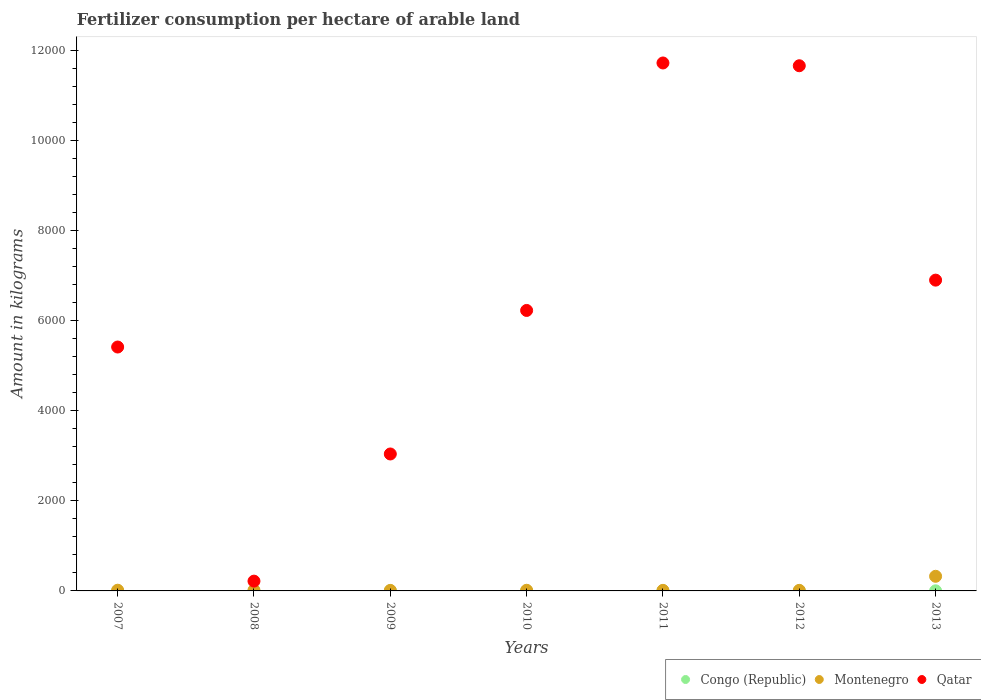How many different coloured dotlines are there?
Offer a terse response. 3. What is the amount of fertilizer consumption in Montenegro in 2011?
Make the answer very short. 12.55. Across all years, what is the maximum amount of fertilizer consumption in Montenegro?
Give a very brief answer. 324.74. Across all years, what is the minimum amount of fertilizer consumption in Montenegro?
Provide a short and direct response. 11.33. In which year was the amount of fertilizer consumption in Congo (Republic) maximum?
Provide a short and direct response. 2009. In which year was the amount of fertilizer consumption in Congo (Republic) minimum?
Make the answer very short. 2007. What is the total amount of fertilizer consumption in Congo (Republic) in the graph?
Your answer should be compact. 10.15. What is the difference between the amount of fertilizer consumption in Montenegro in 2010 and that in 2013?
Your answer should be compact. -310.39. What is the difference between the amount of fertilizer consumption in Congo (Republic) in 2013 and the amount of fertilizer consumption in Montenegro in 2010?
Your answer should be very brief. -12.07. What is the average amount of fertilizer consumption in Montenegro per year?
Offer a very short reply. 57.97. In the year 2011, what is the difference between the amount of fertilizer consumption in Congo (Republic) and amount of fertilizer consumption in Qatar?
Your answer should be compact. -1.17e+04. What is the ratio of the amount of fertilizer consumption in Qatar in 2011 to that in 2013?
Your answer should be compact. 1.7. Is the amount of fertilizer consumption in Congo (Republic) in 2008 less than that in 2010?
Ensure brevity in your answer.  No. What is the difference between the highest and the second highest amount of fertilizer consumption in Congo (Republic)?
Provide a succinct answer. 2.3. What is the difference between the highest and the lowest amount of fertilizer consumption in Montenegro?
Offer a terse response. 313.41. In how many years, is the amount of fertilizer consumption in Qatar greater than the average amount of fertilizer consumption in Qatar taken over all years?
Give a very brief answer. 3. Is the sum of the amount of fertilizer consumption in Montenegro in 2007 and 2011 greater than the maximum amount of fertilizer consumption in Qatar across all years?
Your answer should be very brief. No. Is it the case that in every year, the sum of the amount of fertilizer consumption in Congo (Republic) and amount of fertilizer consumption in Qatar  is greater than the amount of fertilizer consumption in Montenegro?
Your answer should be compact. Yes. Does the amount of fertilizer consumption in Qatar monotonically increase over the years?
Your answer should be compact. No. Is the amount of fertilizer consumption in Montenegro strictly less than the amount of fertilizer consumption in Congo (Republic) over the years?
Keep it short and to the point. No. How many dotlines are there?
Your answer should be very brief. 3. How many years are there in the graph?
Make the answer very short. 7. Does the graph contain any zero values?
Provide a succinct answer. No. Does the graph contain grids?
Provide a short and direct response. No. Where does the legend appear in the graph?
Offer a very short reply. Bottom right. How many legend labels are there?
Ensure brevity in your answer.  3. What is the title of the graph?
Your response must be concise. Fertilizer consumption per hectare of arable land. What is the label or title of the Y-axis?
Provide a succinct answer. Amount in kilograms. What is the Amount in kilograms in Congo (Republic) in 2007?
Your response must be concise. 0.36. What is the Amount in kilograms of Montenegro in 2007?
Your answer should be compact. 15.63. What is the Amount in kilograms in Qatar in 2007?
Make the answer very short. 5413.85. What is the Amount in kilograms in Congo (Republic) in 2008?
Your answer should be very brief. 0.75. What is the Amount in kilograms in Montenegro in 2008?
Keep it short and to the point. 14.79. What is the Amount in kilograms in Qatar in 2008?
Keep it short and to the point. 217.13. What is the Amount in kilograms of Congo (Republic) in 2009?
Your response must be concise. 4.58. What is the Amount in kilograms of Montenegro in 2009?
Keep it short and to the point. 11.33. What is the Amount in kilograms in Qatar in 2009?
Make the answer very short. 3039.68. What is the Amount in kilograms in Congo (Republic) in 2010?
Your response must be concise. 0.54. What is the Amount in kilograms of Montenegro in 2010?
Keep it short and to the point. 14.35. What is the Amount in kilograms of Qatar in 2010?
Your answer should be compact. 6225.78. What is the Amount in kilograms in Congo (Republic) in 2011?
Your answer should be very brief. 0.4. What is the Amount in kilograms of Montenegro in 2011?
Provide a short and direct response. 12.55. What is the Amount in kilograms of Qatar in 2011?
Your answer should be very brief. 1.17e+04. What is the Amount in kilograms of Congo (Republic) in 2012?
Your answer should be very brief. 1.25. What is the Amount in kilograms of Montenegro in 2012?
Give a very brief answer. 12.41. What is the Amount in kilograms of Qatar in 2012?
Your response must be concise. 1.17e+04. What is the Amount in kilograms of Congo (Republic) in 2013?
Offer a terse response. 2.28. What is the Amount in kilograms in Montenegro in 2013?
Make the answer very short. 324.74. What is the Amount in kilograms of Qatar in 2013?
Give a very brief answer. 6898.65. Across all years, what is the maximum Amount in kilograms of Congo (Republic)?
Ensure brevity in your answer.  4.58. Across all years, what is the maximum Amount in kilograms of Montenegro?
Ensure brevity in your answer.  324.74. Across all years, what is the maximum Amount in kilograms of Qatar?
Give a very brief answer. 1.17e+04. Across all years, what is the minimum Amount in kilograms of Congo (Republic)?
Your response must be concise. 0.36. Across all years, what is the minimum Amount in kilograms of Montenegro?
Give a very brief answer. 11.33. Across all years, what is the minimum Amount in kilograms in Qatar?
Make the answer very short. 217.13. What is the total Amount in kilograms of Congo (Republic) in the graph?
Offer a very short reply. 10.15. What is the total Amount in kilograms of Montenegro in the graph?
Your answer should be very brief. 405.81. What is the total Amount in kilograms of Qatar in the graph?
Offer a terse response. 4.52e+04. What is the difference between the Amount in kilograms of Congo (Republic) in 2007 and that in 2008?
Your answer should be very brief. -0.39. What is the difference between the Amount in kilograms of Montenegro in 2007 and that in 2008?
Your response must be concise. 0.84. What is the difference between the Amount in kilograms of Qatar in 2007 and that in 2008?
Your answer should be compact. 5196.72. What is the difference between the Amount in kilograms of Congo (Republic) in 2007 and that in 2009?
Offer a terse response. -4.22. What is the difference between the Amount in kilograms in Montenegro in 2007 and that in 2009?
Make the answer very short. 4.3. What is the difference between the Amount in kilograms of Qatar in 2007 and that in 2009?
Give a very brief answer. 2374.16. What is the difference between the Amount in kilograms in Congo (Republic) in 2007 and that in 2010?
Offer a very short reply. -0.18. What is the difference between the Amount in kilograms of Montenegro in 2007 and that in 2010?
Keep it short and to the point. 1.28. What is the difference between the Amount in kilograms of Qatar in 2007 and that in 2010?
Keep it short and to the point. -811.94. What is the difference between the Amount in kilograms in Congo (Republic) in 2007 and that in 2011?
Offer a very short reply. -0.04. What is the difference between the Amount in kilograms of Montenegro in 2007 and that in 2011?
Ensure brevity in your answer.  3.08. What is the difference between the Amount in kilograms of Qatar in 2007 and that in 2011?
Ensure brevity in your answer.  -6305.08. What is the difference between the Amount in kilograms in Congo (Republic) in 2007 and that in 2012?
Provide a short and direct response. -0.89. What is the difference between the Amount in kilograms in Montenegro in 2007 and that in 2012?
Offer a terse response. 3.22. What is the difference between the Amount in kilograms in Qatar in 2007 and that in 2012?
Your response must be concise. -6243.42. What is the difference between the Amount in kilograms of Congo (Republic) in 2007 and that in 2013?
Make the answer very short. -1.92. What is the difference between the Amount in kilograms of Montenegro in 2007 and that in 2013?
Provide a short and direct response. -309.11. What is the difference between the Amount in kilograms of Qatar in 2007 and that in 2013?
Give a very brief answer. -1484.81. What is the difference between the Amount in kilograms in Congo (Republic) in 2008 and that in 2009?
Offer a terse response. -3.83. What is the difference between the Amount in kilograms in Montenegro in 2008 and that in 2009?
Your response must be concise. 3.46. What is the difference between the Amount in kilograms in Qatar in 2008 and that in 2009?
Offer a very short reply. -2822.55. What is the difference between the Amount in kilograms of Congo (Republic) in 2008 and that in 2010?
Make the answer very short. 0.21. What is the difference between the Amount in kilograms in Montenegro in 2008 and that in 2010?
Keep it short and to the point. 0.44. What is the difference between the Amount in kilograms of Qatar in 2008 and that in 2010?
Offer a very short reply. -6008.65. What is the difference between the Amount in kilograms of Congo (Republic) in 2008 and that in 2011?
Your answer should be compact. 0.35. What is the difference between the Amount in kilograms of Montenegro in 2008 and that in 2011?
Give a very brief answer. 2.24. What is the difference between the Amount in kilograms of Qatar in 2008 and that in 2011?
Ensure brevity in your answer.  -1.15e+04. What is the difference between the Amount in kilograms in Congo (Republic) in 2008 and that in 2012?
Your answer should be compact. -0.5. What is the difference between the Amount in kilograms of Montenegro in 2008 and that in 2012?
Your answer should be very brief. 2.38. What is the difference between the Amount in kilograms of Qatar in 2008 and that in 2012?
Provide a short and direct response. -1.14e+04. What is the difference between the Amount in kilograms in Congo (Republic) in 2008 and that in 2013?
Keep it short and to the point. -1.53. What is the difference between the Amount in kilograms in Montenegro in 2008 and that in 2013?
Ensure brevity in your answer.  -309.95. What is the difference between the Amount in kilograms in Qatar in 2008 and that in 2013?
Ensure brevity in your answer.  -6681.52. What is the difference between the Amount in kilograms of Congo (Republic) in 2009 and that in 2010?
Make the answer very short. 4.04. What is the difference between the Amount in kilograms in Montenegro in 2009 and that in 2010?
Ensure brevity in your answer.  -3.03. What is the difference between the Amount in kilograms in Qatar in 2009 and that in 2010?
Make the answer very short. -3186.1. What is the difference between the Amount in kilograms of Congo (Republic) in 2009 and that in 2011?
Your response must be concise. 4.18. What is the difference between the Amount in kilograms in Montenegro in 2009 and that in 2011?
Provide a succinct answer. -1.22. What is the difference between the Amount in kilograms in Qatar in 2009 and that in 2011?
Offer a terse response. -8679.25. What is the difference between the Amount in kilograms in Congo (Republic) in 2009 and that in 2012?
Offer a terse response. 3.33. What is the difference between the Amount in kilograms in Montenegro in 2009 and that in 2012?
Give a very brief answer. -1.08. What is the difference between the Amount in kilograms in Qatar in 2009 and that in 2012?
Provide a succinct answer. -8617.59. What is the difference between the Amount in kilograms in Congo (Republic) in 2009 and that in 2013?
Provide a short and direct response. 2.3. What is the difference between the Amount in kilograms in Montenegro in 2009 and that in 2013?
Your answer should be very brief. -313.41. What is the difference between the Amount in kilograms in Qatar in 2009 and that in 2013?
Keep it short and to the point. -3858.97. What is the difference between the Amount in kilograms of Congo (Republic) in 2010 and that in 2011?
Keep it short and to the point. 0.14. What is the difference between the Amount in kilograms of Montenegro in 2010 and that in 2011?
Your answer should be compact. 1.81. What is the difference between the Amount in kilograms of Qatar in 2010 and that in 2011?
Keep it short and to the point. -5493.14. What is the difference between the Amount in kilograms of Congo (Republic) in 2010 and that in 2012?
Your response must be concise. -0.7. What is the difference between the Amount in kilograms in Montenegro in 2010 and that in 2012?
Make the answer very short. 1.94. What is the difference between the Amount in kilograms of Qatar in 2010 and that in 2012?
Keep it short and to the point. -5431.49. What is the difference between the Amount in kilograms in Congo (Republic) in 2010 and that in 2013?
Provide a succinct answer. -1.74. What is the difference between the Amount in kilograms of Montenegro in 2010 and that in 2013?
Your answer should be compact. -310.39. What is the difference between the Amount in kilograms in Qatar in 2010 and that in 2013?
Your response must be concise. -672.87. What is the difference between the Amount in kilograms in Congo (Republic) in 2011 and that in 2012?
Your response must be concise. -0.85. What is the difference between the Amount in kilograms of Montenegro in 2011 and that in 2012?
Your response must be concise. 0.14. What is the difference between the Amount in kilograms of Qatar in 2011 and that in 2012?
Ensure brevity in your answer.  61.66. What is the difference between the Amount in kilograms in Congo (Republic) in 2011 and that in 2013?
Ensure brevity in your answer.  -1.89. What is the difference between the Amount in kilograms in Montenegro in 2011 and that in 2013?
Offer a terse response. -312.19. What is the difference between the Amount in kilograms in Qatar in 2011 and that in 2013?
Give a very brief answer. 4820.27. What is the difference between the Amount in kilograms of Congo (Republic) in 2012 and that in 2013?
Ensure brevity in your answer.  -1.04. What is the difference between the Amount in kilograms of Montenegro in 2012 and that in 2013?
Give a very brief answer. -312.33. What is the difference between the Amount in kilograms of Qatar in 2012 and that in 2013?
Offer a very short reply. 4758.62. What is the difference between the Amount in kilograms in Congo (Republic) in 2007 and the Amount in kilograms in Montenegro in 2008?
Your answer should be very brief. -14.43. What is the difference between the Amount in kilograms in Congo (Republic) in 2007 and the Amount in kilograms in Qatar in 2008?
Your answer should be compact. -216.77. What is the difference between the Amount in kilograms in Montenegro in 2007 and the Amount in kilograms in Qatar in 2008?
Provide a short and direct response. -201.5. What is the difference between the Amount in kilograms of Congo (Republic) in 2007 and the Amount in kilograms of Montenegro in 2009?
Give a very brief answer. -10.97. What is the difference between the Amount in kilograms of Congo (Republic) in 2007 and the Amount in kilograms of Qatar in 2009?
Offer a terse response. -3039.32. What is the difference between the Amount in kilograms in Montenegro in 2007 and the Amount in kilograms in Qatar in 2009?
Offer a terse response. -3024.05. What is the difference between the Amount in kilograms of Congo (Republic) in 2007 and the Amount in kilograms of Montenegro in 2010?
Keep it short and to the point. -14. What is the difference between the Amount in kilograms in Congo (Republic) in 2007 and the Amount in kilograms in Qatar in 2010?
Your response must be concise. -6225.42. What is the difference between the Amount in kilograms of Montenegro in 2007 and the Amount in kilograms of Qatar in 2010?
Offer a terse response. -6210.15. What is the difference between the Amount in kilograms of Congo (Republic) in 2007 and the Amount in kilograms of Montenegro in 2011?
Ensure brevity in your answer.  -12.19. What is the difference between the Amount in kilograms of Congo (Republic) in 2007 and the Amount in kilograms of Qatar in 2011?
Keep it short and to the point. -1.17e+04. What is the difference between the Amount in kilograms in Montenegro in 2007 and the Amount in kilograms in Qatar in 2011?
Provide a succinct answer. -1.17e+04. What is the difference between the Amount in kilograms of Congo (Republic) in 2007 and the Amount in kilograms of Montenegro in 2012?
Offer a very short reply. -12.05. What is the difference between the Amount in kilograms of Congo (Republic) in 2007 and the Amount in kilograms of Qatar in 2012?
Offer a very short reply. -1.17e+04. What is the difference between the Amount in kilograms of Montenegro in 2007 and the Amount in kilograms of Qatar in 2012?
Provide a succinct answer. -1.16e+04. What is the difference between the Amount in kilograms of Congo (Republic) in 2007 and the Amount in kilograms of Montenegro in 2013?
Offer a terse response. -324.38. What is the difference between the Amount in kilograms of Congo (Republic) in 2007 and the Amount in kilograms of Qatar in 2013?
Keep it short and to the point. -6898.29. What is the difference between the Amount in kilograms of Montenegro in 2007 and the Amount in kilograms of Qatar in 2013?
Offer a very short reply. -6883.02. What is the difference between the Amount in kilograms of Congo (Republic) in 2008 and the Amount in kilograms of Montenegro in 2009?
Offer a very short reply. -10.58. What is the difference between the Amount in kilograms in Congo (Republic) in 2008 and the Amount in kilograms in Qatar in 2009?
Your answer should be very brief. -3038.94. What is the difference between the Amount in kilograms in Montenegro in 2008 and the Amount in kilograms in Qatar in 2009?
Provide a short and direct response. -3024.89. What is the difference between the Amount in kilograms in Congo (Republic) in 2008 and the Amount in kilograms in Montenegro in 2010?
Offer a terse response. -13.61. What is the difference between the Amount in kilograms of Congo (Republic) in 2008 and the Amount in kilograms of Qatar in 2010?
Ensure brevity in your answer.  -6225.04. What is the difference between the Amount in kilograms of Montenegro in 2008 and the Amount in kilograms of Qatar in 2010?
Make the answer very short. -6210.99. What is the difference between the Amount in kilograms of Congo (Republic) in 2008 and the Amount in kilograms of Montenegro in 2011?
Keep it short and to the point. -11.8. What is the difference between the Amount in kilograms in Congo (Republic) in 2008 and the Amount in kilograms in Qatar in 2011?
Your response must be concise. -1.17e+04. What is the difference between the Amount in kilograms of Montenegro in 2008 and the Amount in kilograms of Qatar in 2011?
Ensure brevity in your answer.  -1.17e+04. What is the difference between the Amount in kilograms in Congo (Republic) in 2008 and the Amount in kilograms in Montenegro in 2012?
Keep it short and to the point. -11.67. What is the difference between the Amount in kilograms of Congo (Republic) in 2008 and the Amount in kilograms of Qatar in 2012?
Your answer should be compact. -1.17e+04. What is the difference between the Amount in kilograms of Montenegro in 2008 and the Amount in kilograms of Qatar in 2012?
Your answer should be very brief. -1.16e+04. What is the difference between the Amount in kilograms in Congo (Republic) in 2008 and the Amount in kilograms in Montenegro in 2013?
Your answer should be very brief. -324. What is the difference between the Amount in kilograms of Congo (Republic) in 2008 and the Amount in kilograms of Qatar in 2013?
Offer a terse response. -6897.91. What is the difference between the Amount in kilograms of Montenegro in 2008 and the Amount in kilograms of Qatar in 2013?
Offer a very short reply. -6883.86. What is the difference between the Amount in kilograms in Congo (Republic) in 2009 and the Amount in kilograms in Montenegro in 2010?
Your answer should be very brief. -9.78. What is the difference between the Amount in kilograms in Congo (Republic) in 2009 and the Amount in kilograms in Qatar in 2010?
Ensure brevity in your answer.  -6221.2. What is the difference between the Amount in kilograms in Montenegro in 2009 and the Amount in kilograms in Qatar in 2010?
Your answer should be compact. -6214.45. What is the difference between the Amount in kilograms of Congo (Republic) in 2009 and the Amount in kilograms of Montenegro in 2011?
Your answer should be compact. -7.97. What is the difference between the Amount in kilograms in Congo (Republic) in 2009 and the Amount in kilograms in Qatar in 2011?
Provide a short and direct response. -1.17e+04. What is the difference between the Amount in kilograms in Montenegro in 2009 and the Amount in kilograms in Qatar in 2011?
Make the answer very short. -1.17e+04. What is the difference between the Amount in kilograms in Congo (Republic) in 2009 and the Amount in kilograms in Montenegro in 2012?
Give a very brief answer. -7.83. What is the difference between the Amount in kilograms in Congo (Republic) in 2009 and the Amount in kilograms in Qatar in 2012?
Offer a terse response. -1.17e+04. What is the difference between the Amount in kilograms of Montenegro in 2009 and the Amount in kilograms of Qatar in 2012?
Offer a very short reply. -1.16e+04. What is the difference between the Amount in kilograms in Congo (Republic) in 2009 and the Amount in kilograms in Montenegro in 2013?
Ensure brevity in your answer.  -320.17. What is the difference between the Amount in kilograms in Congo (Republic) in 2009 and the Amount in kilograms in Qatar in 2013?
Keep it short and to the point. -6894.08. What is the difference between the Amount in kilograms in Montenegro in 2009 and the Amount in kilograms in Qatar in 2013?
Ensure brevity in your answer.  -6887.32. What is the difference between the Amount in kilograms of Congo (Republic) in 2010 and the Amount in kilograms of Montenegro in 2011?
Provide a short and direct response. -12.01. What is the difference between the Amount in kilograms of Congo (Republic) in 2010 and the Amount in kilograms of Qatar in 2011?
Keep it short and to the point. -1.17e+04. What is the difference between the Amount in kilograms in Montenegro in 2010 and the Amount in kilograms in Qatar in 2011?
Offer a terse response. -1.17e+04. What is the difference between the Amount in kilograms of Congo (Republic) in 2010 and the Amount in kilograms of Montenegro in 2012?
Offer a very short reply. -11.87. What is the difference between the Amount in kilograms of Congo (Republic) in 2010 and the Amount in kilograms of Qatar in 2012?
Ensure brevity in your answer.  -1.17e+04. What is the difference between the Amount in kilograms of Montenegro in 2010 and the Amount in kilograms of Qatar in 2012?
Ensure brevity in your answer.  -1.16e+04. What is the difference between the Amount in kilograms of Congo (Republic) in 2010 and the Amount in kilograms of Montenegro in 2013?
Your answer should be compact. -324.2. What is the difference between the Amount in kilograms of Congo (Republic) in 2010 and the Amount in kilograms of Qatar in 2013?
Give a very brief answer. -6898.11. What is the difference between the Amount in kilograms of Montenegro in 2010 and the Amount in kilograms of Qatar in 2013?
Ensure brevity in your answer.  -6884.3. What is the difference between the Amount in kilograms in Congo (Republic) in 2011 and the Amount in kilograms in Montenegro in 2012?
Offer a terse response. -12.02. What is the difference between the Amount in kilograms in Congo (Republic) in 2011 and the Amount in kilograms in Qatar in 2012?
Offer a very short reply. -1.17e+04. What is the difference between the Amount in kilograms of Montenegro in 2011 and the Amount in kilograms of Qatar in 2012?
Keep it short and to the point. -1.16e+04. What is the difference between the Amount in kilograms in Congo (Republic) in 2011 and the Amount in kilograms in Montenegro in 2013?
Ensure brevity in your answer.  -324.35. What is the difference between the Amount in kilograms of Congo (Republic) in 2011 and the Amount in kilograms of Qatar in 2013?
Your answer should be compact. -6898.26. What is the difference between the Amount in kilograms in Montenegro in 2011 and the Amount in kilograms in Qatar in 2013?
Offer a terse response. -6886.1. What is the difference between the Amount in kilograms in Congo (Republic) in 2012 and the Amount in kilograms in Montenegro in 2013?
Make the answer very short. -323.5. What is the difference between the Amount in kilograms in Congo (Republic) in 2012 and the Amount in kilograms in Qatar in 2013?
Your answer should be very brief. -6897.41. What is the difference between the Amount in kilograms of Montenegro in 2012 and the Amount in kilograms of Qatar in 2013?
Ensure brevity in your answer.  -6886.24. What is the average Amount in kilograms in Congo (Republic) per year?
Your answer should be compact. 1.45. What is the average Amount in kilograms of Montenegro per year?
Keep it short and to the point. 57.97. What is the average Amount in kilograms of Qatar per year?
Make the answer very short. 6453.04. In the year 2007, what is the difference between the Amount in kilograms of Congo (Republic) and Amount in kilograms of Montenegro?
Give a very brief answer. -15.27. In the year 2007, what is the difference between the Amount in kilograms of Congo (Republic) and Amount in kilograms of Qatar?
Keep it short and to the point. -5413.49. In the year 2007, what is the difference between the Amount in kilograms of Montenegro and Amount in kilograms of Qatar?
Ensure brevity in your answer.  -5398.21. In the year 2008, what is the difference between the Amount in kilograms of Congo (Republic) and Amount in kilograms of Montenegro?
Make the answer very short. -14.04. In the year 2008, what is the difference between the Amount in kilograms of Congo (Republic) and Amount in kilograms of Qatar?
Ensure brevity in your answer.  -216.38. In the year 2008, what is the difference between the Amount in kilograms in Montenegro and Amount in kilograms in Qatar?
Your answer should be very brief. -202.34. In the year 2009, what is the difference between the Amount in kilograms in Congo (Republic) and Amount in kilograms in Montenegro?
Your response must be concise. -6.75. In the year 2009, what is the difference between the Amount in kilograms of Congo (Republic) and Amount in kilograms of Qatar?
Keep it short and to the point. -3035.1. In the year 2009, what is the difference between the Amount in kilograms in Montenegro and Amount in kilograms in Qatar?
Provide a short and direct response. -3028.35. In the year 2010, what is the difference between the Amount in kilograms of Congo (Republic) and Amount in kilograms of Montenegro?
Provide a short and direct response. -13.81. In the year 2010, what is the difference between the Amount in kilograms of Congo (Republic) and Amount in kilograms of Qatar?
Provide a short and direct response. -6225.24. In the year 2010, what is the difference between the Amount in kilograms of Montenegro and Amount in kilograms of Qatar?
Keep it short and to the point. -6211.43. In the year 2011, what is the difference between the Amount in kilograms in Congo (Republic) and Amount in kilograms in Montenegro?
Provide a succinct answer. -12.15. In the year 2011, what is the difference between the Amount in kilograms of Congo (Republic) and Amount in kilograms of Qatar?
Keep it short and to the point. -1.17e+04. In the year 2011, what is the difference between the Amount in kilograms in Montenegro and Amount in kilograms in Qatar?
Ensure brevity in your answer.  -1.17e+04. In the year 2012, what is the difference between the Amount in kilograms of Congo (Republic) and Amount in kilograms of Montenegro?
Keep it short and to the point. -11.17. In the year 2012, what is the difference between the Amount in kilograms in Congo (Republic) and Amount in kilograms in Qatar?
Make the answer very short. -1.17e+04. In the year 2012, what is the difference between the Amount in kilograms in Montenegro and Amount in kilograms in Qatar?
Your answer should be compact. -1.16e+04. In the year 2013, what is the difference between the Amount in kilograms in Congo (Republic) and Amount in kilograms in Montenegro?
Offer a very short reply. -322.46. In the year 2013, what is the difference between the Amount in kilograms of Congo (Republic) and Amount in kilograms of Qatar?
Offer a very short reply. -6896.37. In the year 2013, what is the difference between the Amount in kilograms in Montenegro and Amount in kilograms in Qatar?
Make the answer very short. -6573.91. What is the ratio of the Amount in kilograms in Congo (Republic) in 2007 to that in 2008?
Offer a terse response. 0.48. What is the ratio of the Amount in kilograms in Montenegro in 2007 to that in 2008?
Your answer should be very brief. 1.06. What is the ratio of the Amount in kilograms in Qatar in 2007 to that in 2008?
Make the answer very short. 24.93. What is the ratio of the Amount in kilograms of Congo (Republic) in 2007 to that in 2009?
Ensure brevity in your answer.  0.08. What is the ratio of the Amount in kilograms of Montenegro in 2007 to that in 2009?
Make the answer very short. 1.38. What is the ratio of the Amount in kilograms in Qatar in 2007 to that in 2009?
Offer a very short reply. 1.78. What is the ratio of the Amount in kilograms of Congo (Republic) in 2007 to that in 2010?
Your response must be concise. 0.66. What is the ratio of the Amount in kilograms of Montenegro in 2007 to that in 2010?
Offer a very short reply. 1.09. What is the ratio of the Amount in kilograms of Qatar in 2007 to that in 2010?
Your answer should be compact. 0.87. What is the ratio of the Amount in kilograms in Congo (Republic) in 2007 to that in 2011?
Make the answer very short. 0.91. What is the ratio of the Amount in kilograms in Montenegro in 2007 to that in 2011?
Provide a succinct answer. 1.25. What is the ratio of the Amount in kilograms in Qatar in 2007 to that in 2011?
Offer a terse response. 0.46. What is the ratio of the Amount in kilograms of Congo (Republic) in 2007 to that in 2012?
Provide a short and direct response. 0.29. What is the ratio of the Amount in kilograms in Montenegro in 2007 to that in 2012?
Offer a very short reply. 1.26. What is the ratio of the Amount in kilograms of Qatar in 2007 to that in 2012?
Your answer should be very brief. 0.46. What is the ratio of the Amount in kilograms of Congo (Republic) in 2007 to that in 2013?
Your answer should be compact. 0.16. What is the ratio of the Amount in kilograms in Montenegro in 2007 to that in 2013?
Your answer should be very brief. 0.05. What is the ratio of the Amount in kilograms in Qatar in 2007 to that in 2013?
Provide a short and direct response. 0.78. What is the ratio of the Amount in kilograms in Congo (Republic) in 2008 to that in 2009?
Your answer should be compact. 0.16. What is the ratio of the Amount in kilograms in Montenegro in 2008 to that in 2009?
Give a very brief answer. 1.31. What is the ratio of the Amount in kilograms in Qatar in 2008 to that in 2009?
Keep it short and to the point. 0.07. What is the ratio of the Amount in kilograms in Congo (Republic) in 2008 to that in 2010?
Your answer should be very brief. 1.38. What is the ratio of the Amount in kilograms in Montenegro in 2008 to that in 2010?
Offer a very short reply. 1.03. What is the ratio of the Amount in kilograms in Qatar in 2008 to that in 2010?
Provide a succinct answer. 0.03. What is the ratio of the Amount in kilograms of Congo (Republic) in 2008 to that in 2011?
Give a very brief answer. 1.89. What is the ratio of the Amount in kilograms in Montenegro in 2008 to that in 2011?
Offer a very short reply. 1.18. What is the ratio of the Amount in kilograms in Qatar in 2008 to that in 2011?
Your answer should be compact. 0.02. What is the ratio of the Amount in kilograms in Congo (Republic) in 2008 to that in 2012?
Your answer should be very brief. 0.6. What is the ratio of the Amount in kilograms of Montenegro in 2008 to that in 2012?
Provide a short and direct response. 1.19. What is the ratio of the Amount in kilograms in Qatar in 2008 to that in 2012?
Provide a succinct answer. 0.02. What is the ratio of the Amount in kilograms of Congo (Republic) in 2008 to that in 2013?
Your answer should be very brief. 0.33. What is the ratio of the Amount in kilograms in Montenegro in 2008 to that in 2013?
Your answer should be compact. 0.05. What is the ratio of the Amount in kilograms of Qatar in 2008 to that in 2013?
Give a very brief answer. 0.03. What is the ratio of the Amount in kilograms in Congo (Republic) in 2009 to that in 2010?
Your answer should be very brief. 8.46. What is the ratio of the Amount in kilograms of Montenegro in 2009 to that in 2010?
Your answer should be very brief. 0.79. What is the ratio of the Amount in kilograms in Qatar in 2009 to that in 2010?
Provide a short and direct response. 0.49. What is the ratio of the Amount in kilograms in Congo (Republic) in 2009 to that in 2011?
Offer a terse response. 11.55. What is the ratio of the Amount in kilograms of Montenegro in 2009 to that in 2011?
Give a very brief answer. 0.9. What is the ratio of the Amount in kilograms of Qatar in 2009 to that in 2011?
Your response must be concise. 0.26. What is the ratio of the Amount in kilograms of Congo (Republic) in 2009 to that in 2012?
Your answer should be compact. 3.68. What is the ratio of the Amount in kilograms of Montenegro in 2009 to that in 2012?
Provide a short and direct response. 0.91. What is the ratio of the Amount in kilograms of Qatar in 2009 to that in 2012?
Make the answer very short. 0.26. What is the ratio of the Amount in kilograms in Congo (Republic) in 2009 to that in 2013?
Your response must be concise. 2.01. What is the ratio of the Amount in kilograms in Montenegro in 2009 to that in 2013?
Offer a very short reply. 0.03. What is the ratio of the Amount in kilograms in Qatar in 2009 to that in 2013?
Offer a terse response. 0.44. What is the ratio of the Amount in kilograms in Congo (Republic) in 2010 to that in 2011?
Give a very brief answer. 1.37. What is the ratio of the Amount in kilograms of Montenegro in 2010 to that in 2011?
Provide a short and direct response. 1.14. What is the ratio of the Amount in kilograms in Qatar in 2010 to that in 2011?
Ensure brevity in your answer.  0.53. What is the ratio of the Amount in kilograms of Congo (Republic) in 2010 to that in 2012?
Keep it short and to the point. 0.43. What is the ratio of the Amount in kilograms in Montenegro in 2010 to that in 2012?
Your answer should be very brief. 1.16. What is the ratio of the Amount in kilograms in Qatar in 2010 to that in 2012?
Your answer should be very brief. 0.53. What is the ratio of the Amount in kilograms of Congo (Republic) in 2010 to that in 2013?
Make the answer very short. 0.24. What is the ratio of the Amount in kilograms of Montenegro in 2010 to that in 2013?
Your answer should be compact. 0.04. What is the ratio of the Amount in kilograms of Qatar in 2010 to that in 2013?
Your response must be concise. 0.9. What is the ratio of the Amount in kilograms in Congo (Republic) in 2011 to that in 2012?
Your answer should be very brief. 0.32. What is the ratio of the Amount in kilograms in Qatar in 2011 to that in 2012?
Offer a terse response. 1.01. What is the ratio of the Amount in kilograms of Congo (Republic) in 2011 to that in 2013?
Your answer should be very brief. 0.17. What is the ratio of the Amount in kilograms in Montenegro in 2011 to that in 2013?
Give a very brief answer. 0.04. What is the ratio of the Amount in kilograms of Qatar in 2011 to that in 2013?
Your answer should be compact. 1.7. What is the ratio of the Amount in kilograms of Congo (Republic) in 2012 to that in 2013?
Keep it short and to the point. 0.55. What is the ratio of the Amount in kilograms of Montenegro in 2012 to that in 2013?
Give a very brief answer. 0.04. What is the ratio of the Amount in kilograms of Qatar in 2012 to that in 2013?
Provide a short and direct response. 1.69. What is the difference between the highest and the second highest Amount in kilograms in Congo (Republic)?
Your response must be concise. 2.3. What is the difference between the highest and the second highest Amount in kilograms of Montenegro?
Provide a short and direct response. 309.11. What is the difference between the highest and the second highest Amount in kilograms of Qatar?
Make the answer very short. 61.66. What is the difference between the highest and the lowest Amount in kilograms in Congo (Republic)?
Keep it short and to the point. 4.22. What is the difference between the highest and the lowest Amount in kilograms of Montenegro?
Ensure brevity in your answer.  313.41. What is the difference between the highest and the lowest Amount in kilograms of Qatar?
Your answer should be very brief. 1.15e+04. 